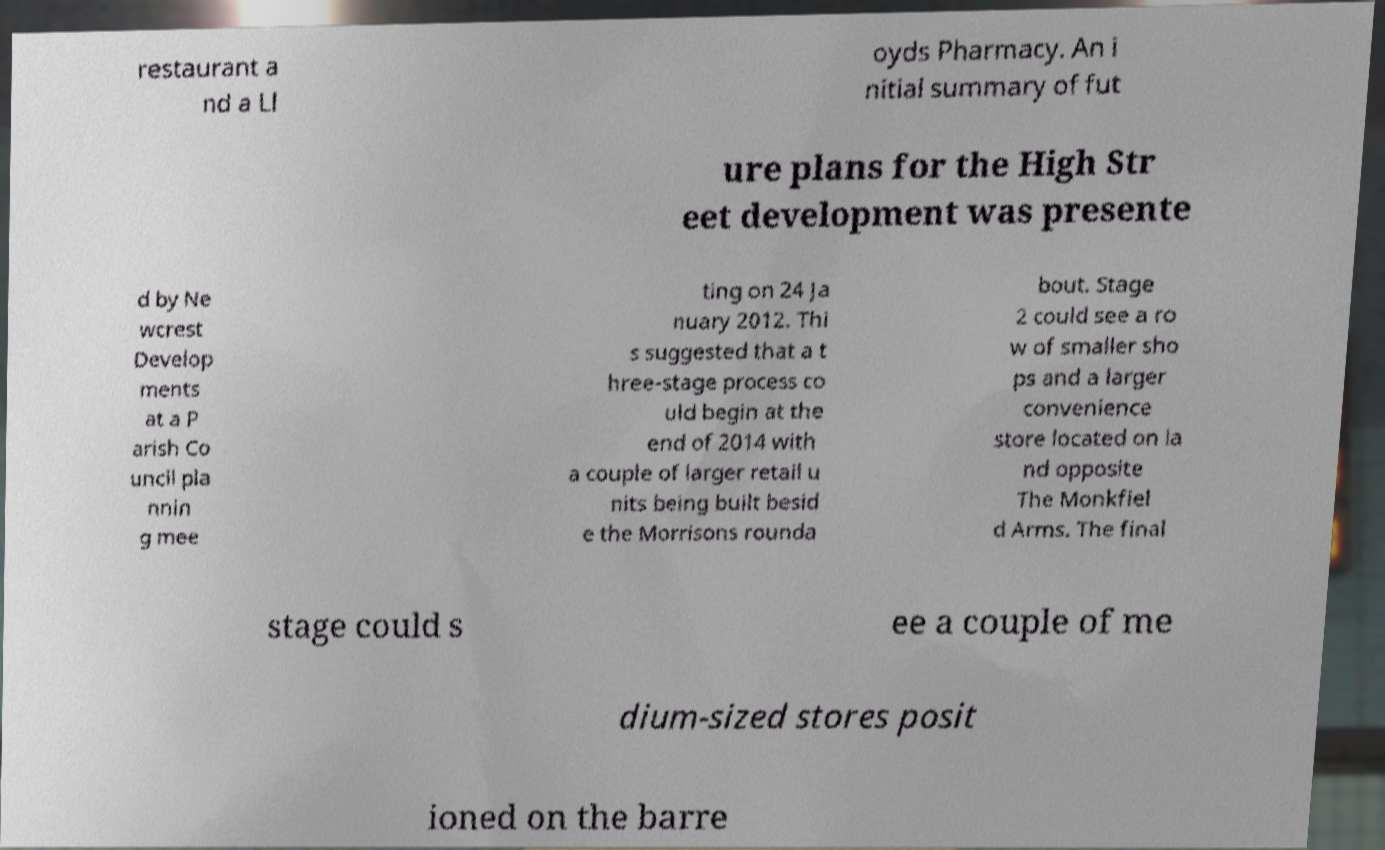Could you assist in decoding the text presented in this image and type it out clearly? restaurant a nd a Ll oyds Pharmacy. An i nitial summary of fut ure plans for the High Str eet development was presente d by Ne wcrest Develop ments at a P arish Co uncil pla nnin g mee ting on 24 Ja nuary 2012. Thi s suggested that a t hree-stage process co uld begin at the end of 2014 with a couple of larger retail u nits being built besid e the Morrisons rounda bout. Stage 2 could see a ro w of smaller sho ps and a larger convenience store located on la nd opposite The Monkfiel d Arms. The final stage could s ee a couple of me dium-sized stores posit ioned on the barre 